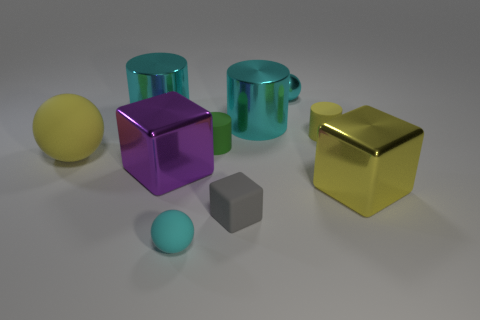Subtract all cylinders. How many objects are left? 6 Add 7 purple cubes. How many purple cubes are left? 8 Add 4 large balls. How many large balls exist? 5 Subtract 1 cyan balls. How many objects are left? 9 Subtract all cyan rubber objects. Subtract all yellow metallic cubes. How many objects are left? 8 